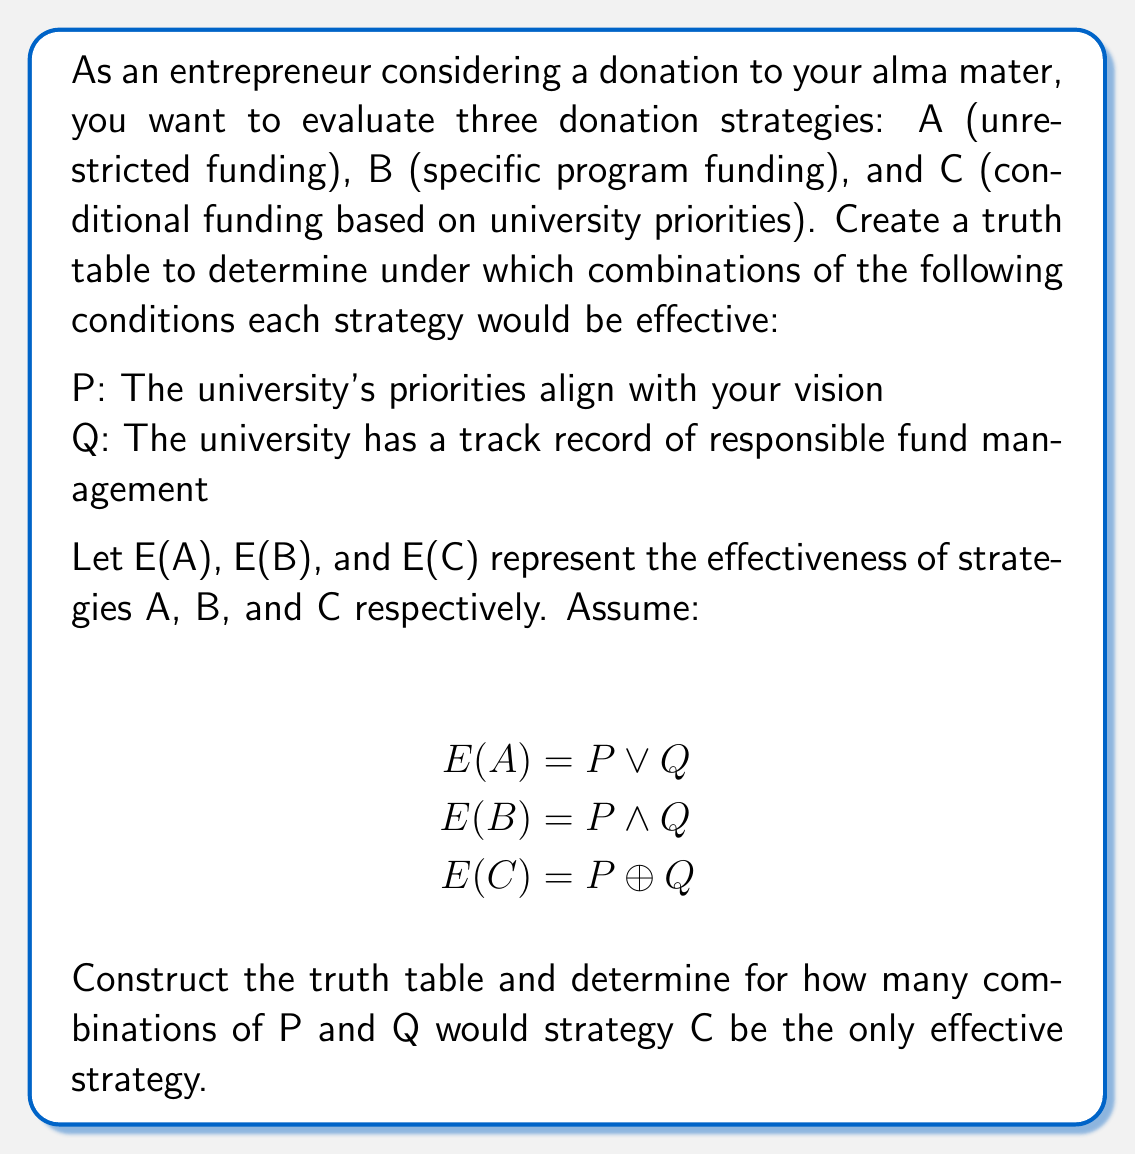What is the answer to this math problem? Let's approach this step-by-step:

1) First, we need to create a truth table with columns for P, Q, E(A), E(B), and E(C).

2) We'll have 4 rows for all possible combinations of P and Q.

3) For each row, we'll calculate E(A), E(B), and E(C) based on the given formulas:

   $$E(A) = P \lor Q$$ (OR operation)
   $$E(B) = P \land Q$$ (AND operation)
   $$E(C) = P \oplus Q$$ (XOR operation)

4) Here's the truth table:

   | P | Q | E(A) | E(B) | E(C) |
   |---|---|------|------|------|
   | 0 | 0 |  0   |  0   |  0   |
   | 0 | 1 |  1   |  0   |  1   |
   | 1 | 0 |  1   |  0   |  1   |
   | 1 | 1 |  1   |  1   |  0   |

5) Now, we need to identify in how many rows E(C) is 1 (effective) while both E(A) and E(B) are 0 (ineffective).

6) Looking at the table:
   - When P=0 and Q=0, all strategies are ineffective.
   - When P=0 and Q=1, both A and C are effective.
   - When P=1 and Q=0, both A and C are effective.
   - When P=1 and Q=1, only A and B are effective.

7) We can see that there are no combinations where C is the only effective strategy.
Answer: 0 